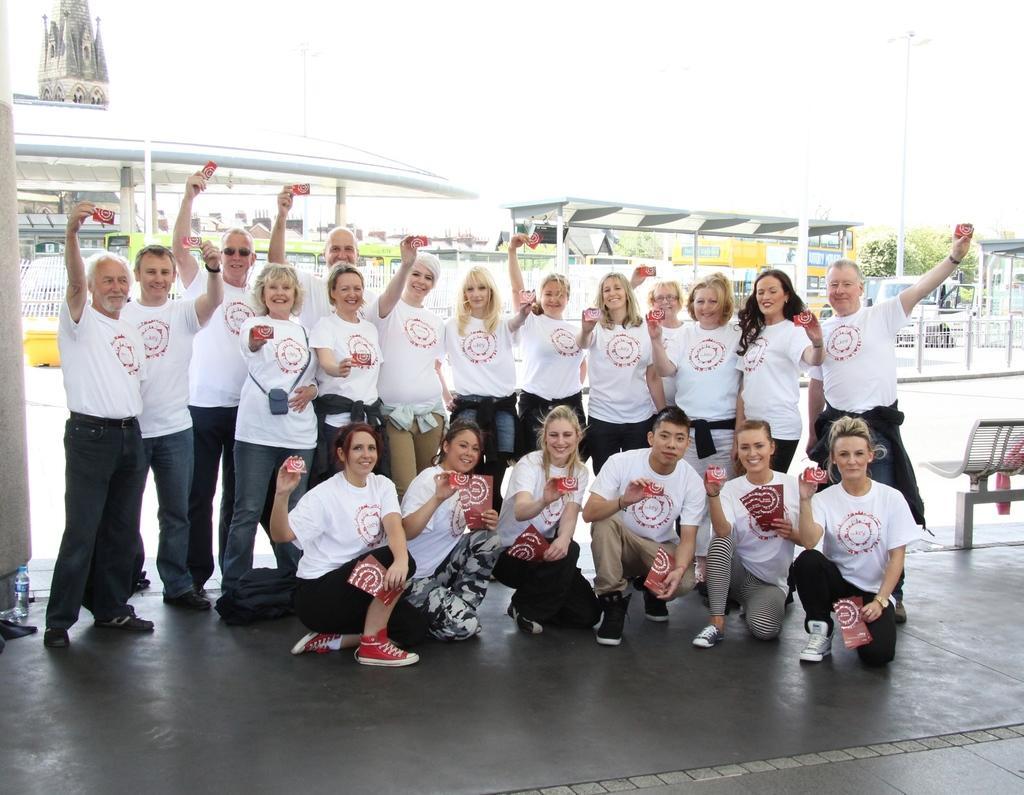How would you summarize this image in a sentence or two? In this picture I can see there is a group of people standing and they are wearing white shirts, they are holding cards, few of them are standing and few are sitting. In the backdrop there is a building and there is a pole, tree and a bench. 